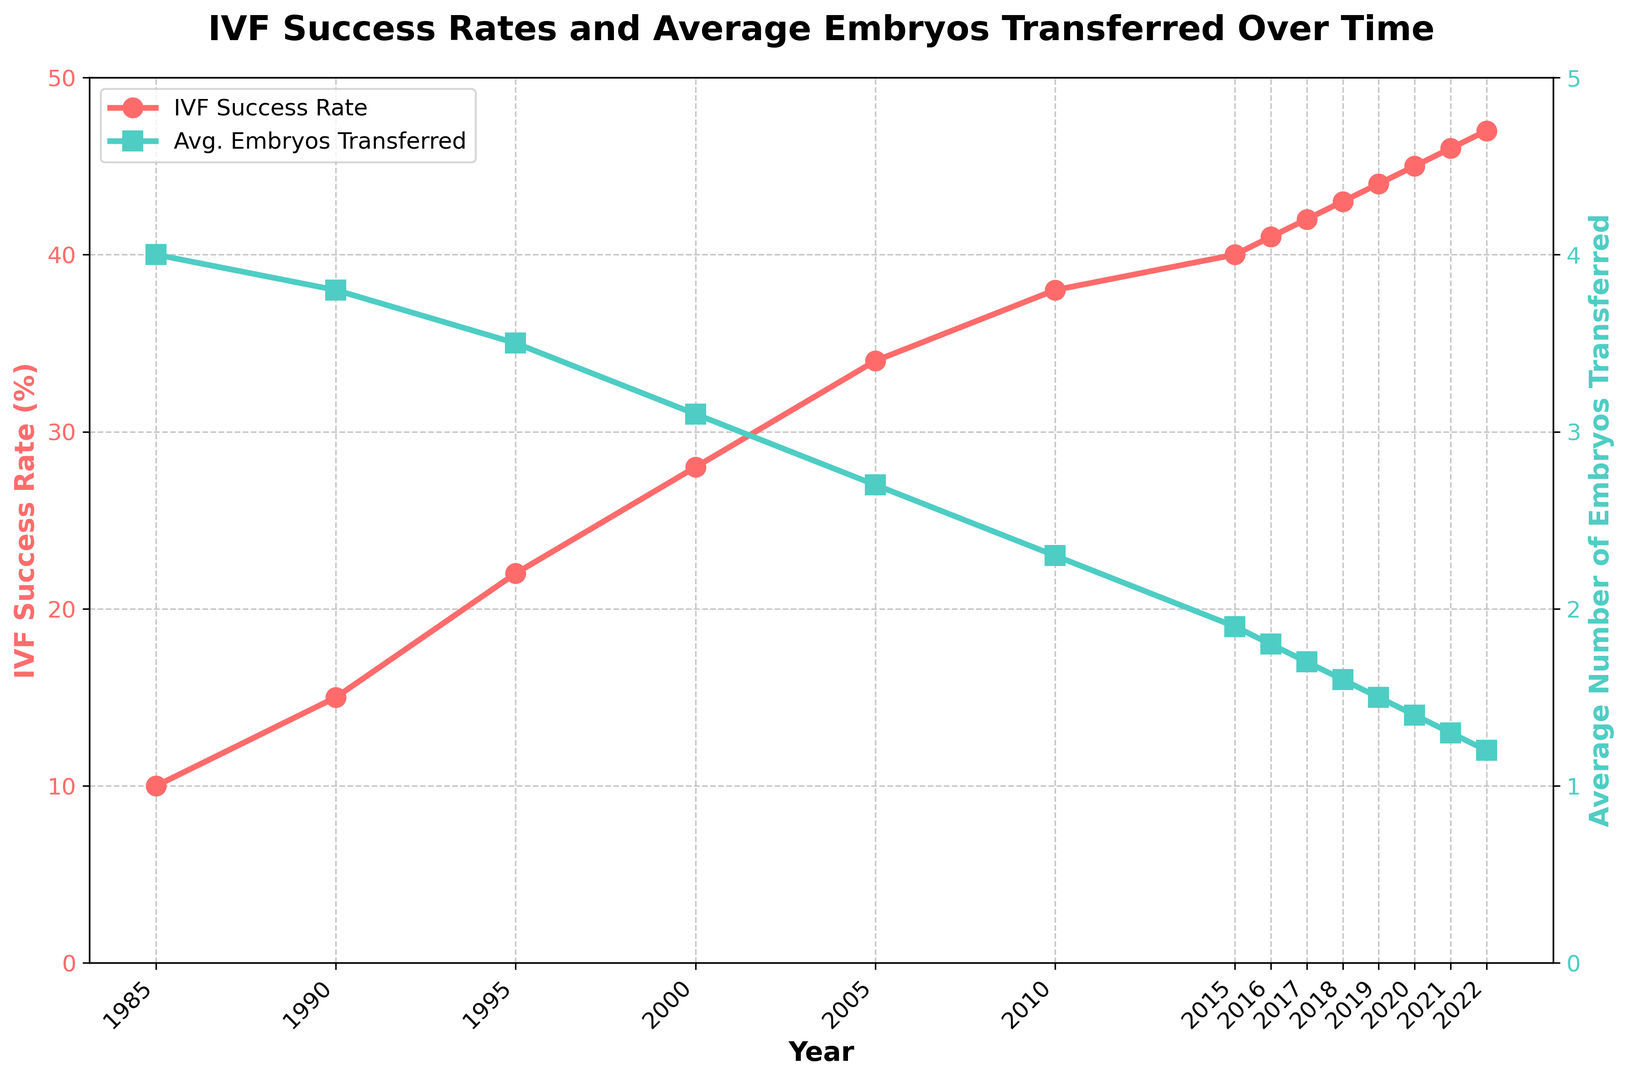Which year had the highest IVF success rate? The highest point on the red line represents the highest IVF success rate. This occurs in 2022.
Answer: 2022 What was the IVF success rate in 2012? The year 2012 is not explicitly mentioned, but by looking closer at the years within proximity and interpolating, you can see that 2012 is between 2010 and 2015. In 2010, the rate was 38%, and in 2015, it was 40%. The rate for 2012 can be estimated to be around 39%.
Answer: 39% How many embryos were transferred on average in 2010? Look at the green line which represents the average number of embryos transferred and locate the year 2010. The value is 2.3 embryos.
Answer: 2.3 What is the difference in IVF success rate between 1990 and 2022? The IVF success rate in 1990 was 15%, and it increased to 47% in 2022. The difference is 47% - 15% = 32%.
Answer: 32% Which year saw the greatest decrease in the average number of embryos transferred compared to the previous year? Look for the steepest drop in the green line. The most significant decrease can be observed between 2019 and 2020, where it drops from 1.5 to 1.4.
Answer: 2020 In which year did the average number of embryos transferred drop below 2.0 for the first time? Find the point on the green line when it first goes below the 2.0 mark. This happens in 2015, where the average number of embryos transferred is 1.9.
Answer: 2015 By how much did the average number of embryos transferred decrease from 1985 to 1995? The average number of embryos transferred in 1985 was 4.0. In 1995, it was 3.5. The decrease is 4.0 - 3.5 = 0.5.
Answer: 0.5 If the trend continues, predict the IVF success rate for the year 2024. Projecting the trend of the red line forward, noting that it approximately increases by 1% each year, the IVF success rate in 2024 could be around 48-49%.
Answer: 48-49% What are the respective colors of the lines representing the IVF success rate and the average number of embryos transferred? The color representing IVF success rate is red, and the color representing average number of embryos transferred is green.
Answer: Red and Green Is there any year where the IVF success rate and the average number of embryos transferred both increased compared to the previous year? All years seem to follow the general trend of the IVF success rate increasing and the average number of embryos transferred decreasing. There is no year where both metrics increased simultaneously.
Answer: No 